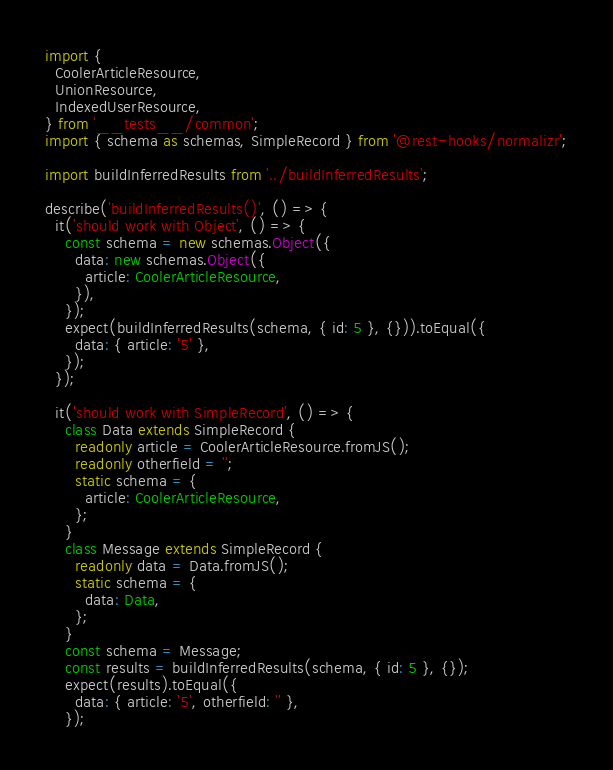<code> <loc_0><loc_0><loc_500><loc_500><_TypeScript_>import {
  CoolerArticleResource,
  UnionResource,
  IndexedUserResource,
} from '__tests__/common';
import { schema as schemas, SimpleRecord } from '@rest-hooks/normalizr';

import buildInferredResults from '../buildInferredResults';

describe('buildInferredResults()', () => {
  it('should work with Object', () => {
    const schema = new schemas.Object({
      data: new schemas.Object({
        article: CoolerArticleResource,
      }),
    });
    expect(buildInferredResults(schema, { id: 5 }, {})).toEqual({
      data: { article: '5' },
    });
  });

  it('should work with SimpleRecord', () => {
    class Data extends SimpleRecord {
      readonly article = CoolerArticleResource.fromJS();
      readonly otherfield = '';
      static schema = {
        article: CoolerArticleResource,
      };
    }
    class Message extends SimpleRecord {
      readonly data = Data.fromJS();
      static schema = {
        data: Data,
      };
    }
    const schema = Message;
    const results = buildInferredResults(schema, { id: 5 }, {});
    expect(results).toEqual({
      data: { article: '5', otherfield: '' },
    });</code> 